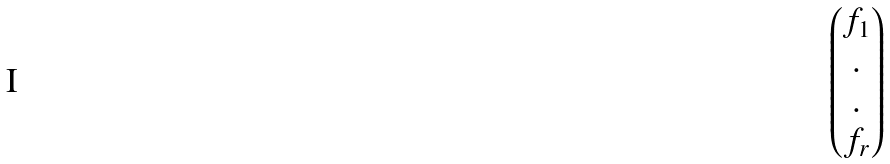<formula> <loc_0><loc_0><loc_500><loc_500>\begin{pmatrix} f _ { 1 } \\ . \\ . \\ f _ { r } \end{pmatrix}</formula> 